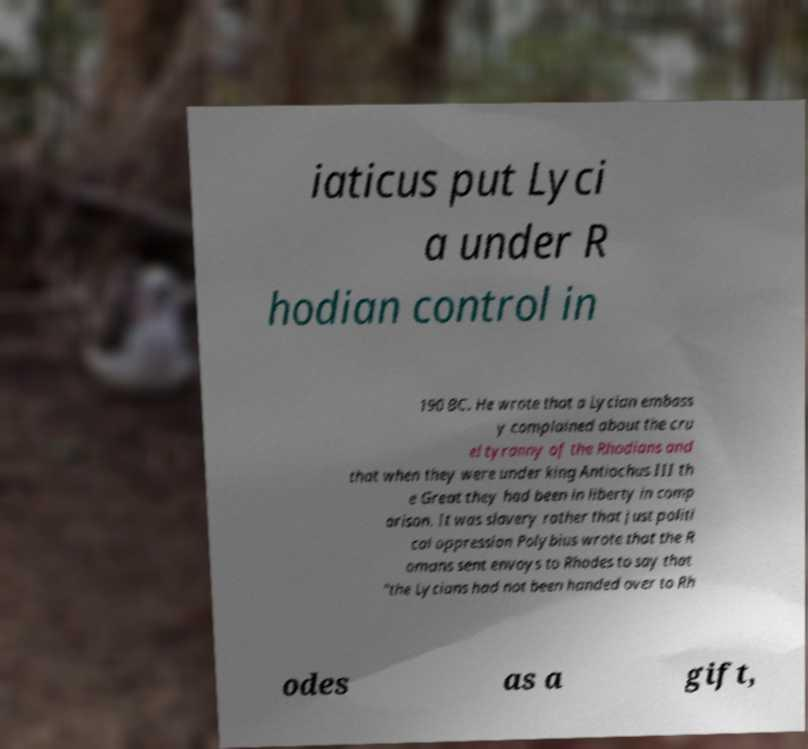Could you assist in decoding the text presented in this image and type it out clearly? iaticus put Lyci a under R hodian control in 190 BC. He wrote that a Lycian embass y complained about the cru el tyranny of the Rhodians and that when they were under king Antiochus III th e Great they had been in liberty in comp arison. It was slavery rather that just politi cal oppression Polybius wrote that the R omans sent envoys to Rhodes to say that "the Lycians had not been handed over to Rh odes as a gift, 